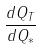Convert formula to latex. <formula><loc_0><loc_0><loc_500><loc_500>\frac { d Q _ { T } } { d Q _ { * } }</formula> 